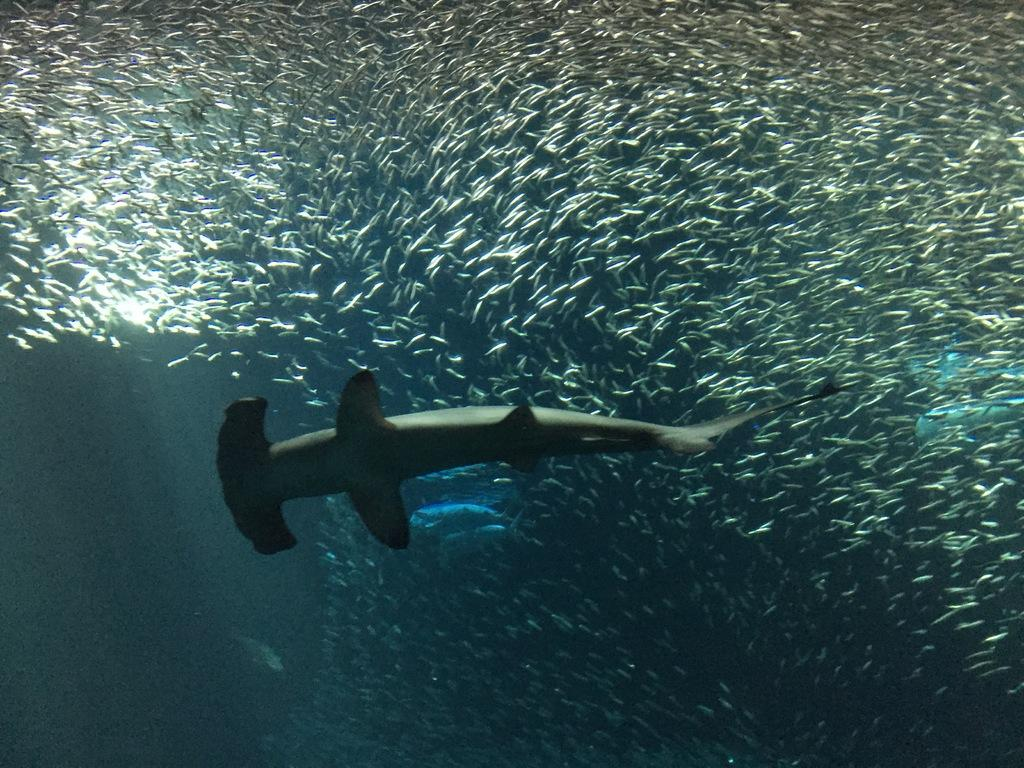What type of animals can be seen in the image? There are big fishes and small fishes in the image. Where are the fishes located? The fishes are underwater. Can you describe the size difference between the two types of fishes? The big fishes are larger than the small fishes. What type of motion can be seen in the image? There is no specific motion visible in the image, as it is a still image of fishes underwater. 